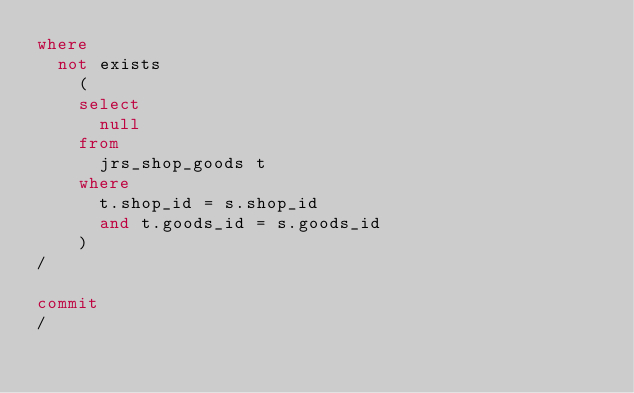<code> <loc_0><loc_0><loc_500><loc_500><_SQL_>where
  not exists
    (
    select
      null
    from
      jrs_shop_goods t
    where
      t.shop_id = s.shop_id
      and t.goods_id = s.goods_id
    )
/

commit
/
</code> 